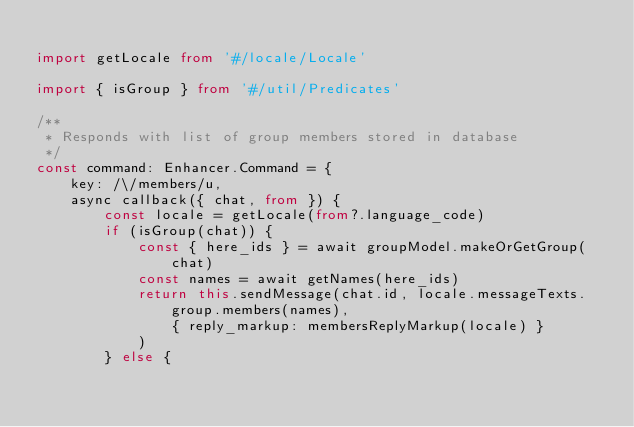Convert code to text. <code><loc_0><loc_0><loc_500><loc_500><_TypeScript_>
import getLocale from '#/locale/Locale'

import { isGroup } from '#/util/Predicates'

/**
 * Responds with list of group members stored in database
 */
const command: Enhancer.Command = {
    key: /\/members/u,
    async callback({ chat, from }) {
        const locale = getLocale(from?.language_code)
        if (isGroup(chat)) {
            const { here_ids } = await groupModel.makeOrGetGroup(chat)
            const names = await getNames(here_ids)
            return this.sendMessage(chat.id, locale.messageTexts.group.members(names),
                { reply_markup: membersReplyMarkup(locale) }
            )
        } else {</code> 